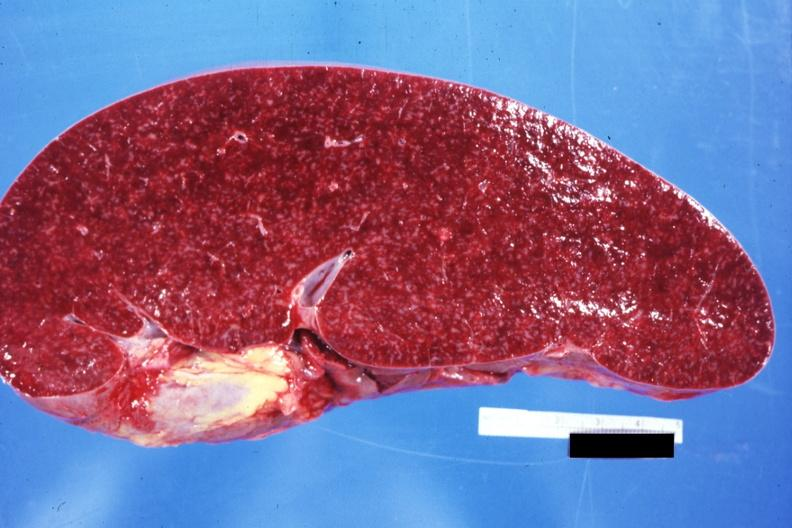what does this image show?
Answer the question using a single word or phrase. Cut surface prominent lymph follicles size appears normal see other sides case 